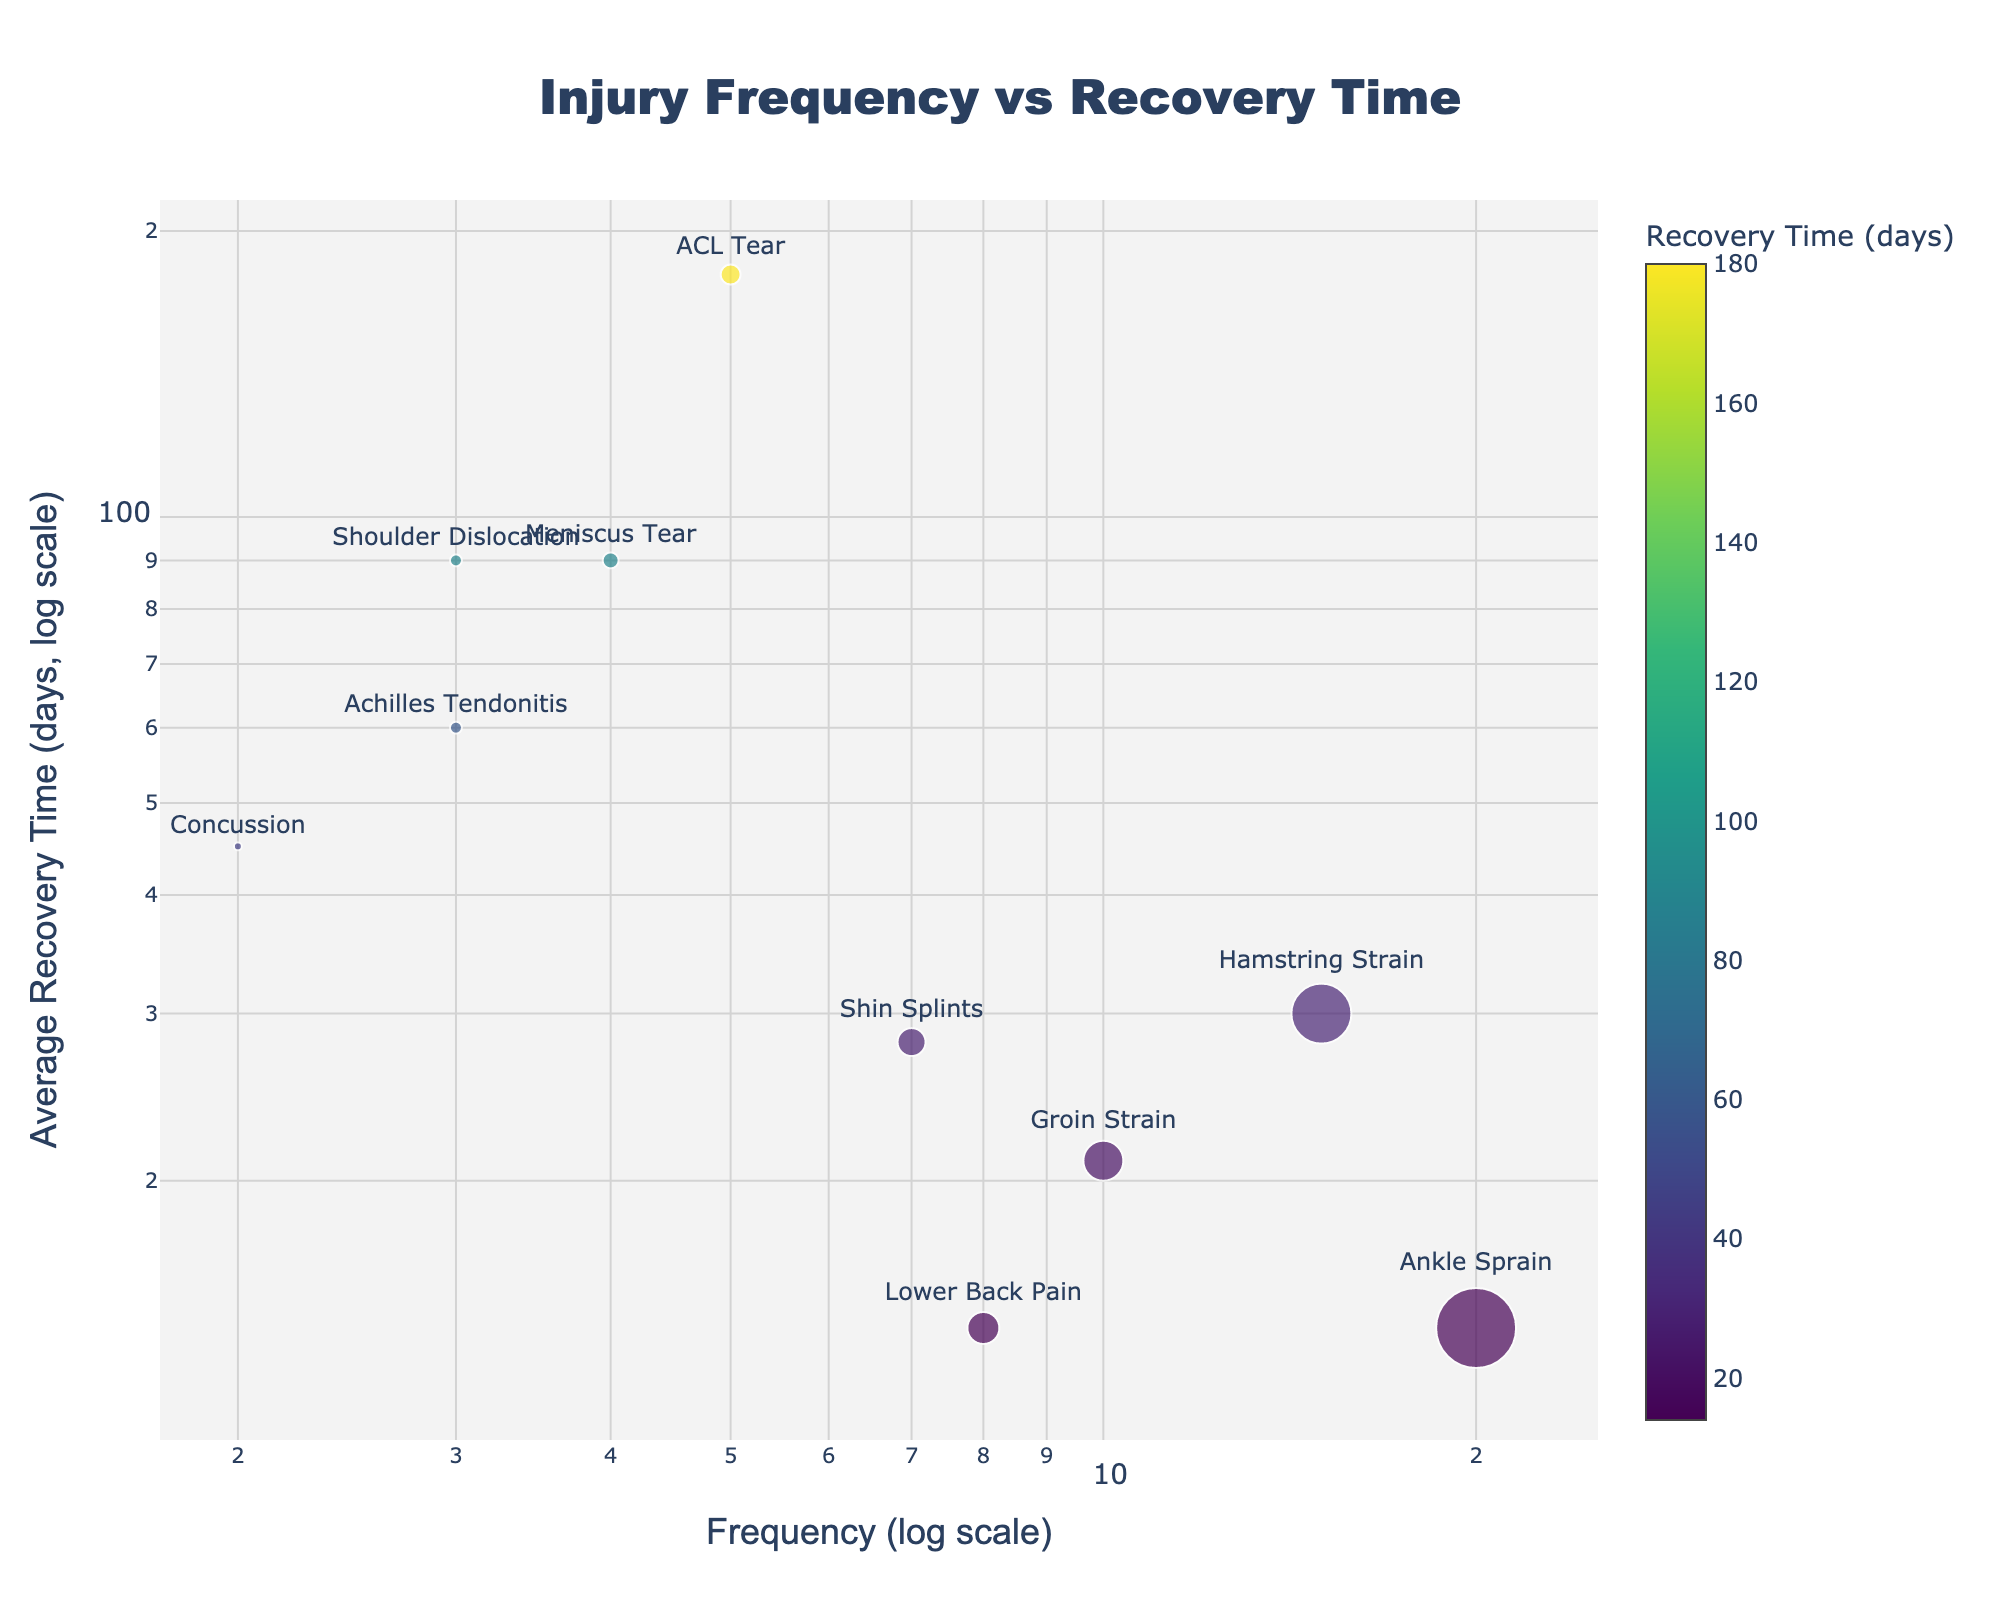What is the title of the plot? The title is often found at the top of the plot and summarizes the content. Here it reads 'Injury Frequency vs Recovery Time'.
Answer: Injury Frequency vs Recovery Time What are the x and y axes titles? The x-axis title can be read along the horizontal axis, and the y-axis title is along the vertical axis. Here, the x-axis title is 'Frequency (log scale)' and the y-axis title is 'Average Recovery Time (days, log scale)'.
Answer: Frequency (log scale); Average Recovery Time (days, log scale) How many types of injuries are plotted in the figure? Count each unique 'Injury Type' label. There are 10 in total.
Answer: 10 Which injury type has the highest frequency and what is its value? Locate the points with the largest x-axis value. 'Ankle Sprain' has the highest frequency with a value of 20.
Answer: Ankle Sprain with a frequency of 20 What is the injury with the longest recovery time? Locate the point furthest up on the y-axis. 'ACL Tear' has the longest recovery time of 180 days.
Answer: ACL Tear with 180 days Which injuries have a recovery time of 90 days? Identify all points along the y-axis value of 90. They are 'Meniscus Tear' and 'Shoulder Dislocation'.
Answer: Meniscus Tear and Shoulder Dislocation What is the recovery time for 'Lower Back Pain'? Find the data point labeled 'Lower Back Pain' and read the y-axis value. It is 14 days.
Answer: 14 days Compare the frequencies of 'Hamstring Strain' and 'Groin Strain'. Which is greater? 'Hamstring Strain' has a frequency of 15 while 'Groin Strain' has 10. Hence, 'Hamstring Strain' is greater.
Answer: Hamstring Strain What is the sum of frequencies of 'Shin Splints' and 'Lower Back Pain'? Add the frequencies of 'Shin Splints' (7) and 'Lower Back Pain' (8): 7 + 8 = 15.
Answer: 15 Which injury type has the same frequency as 'Achilles Tendonitis' and what is its frequency? 'Achilles Tendonitis' and 'Shoulder Dislocation' both have a frequency of 3.
Answer: Shoulder Dislocation with 3 